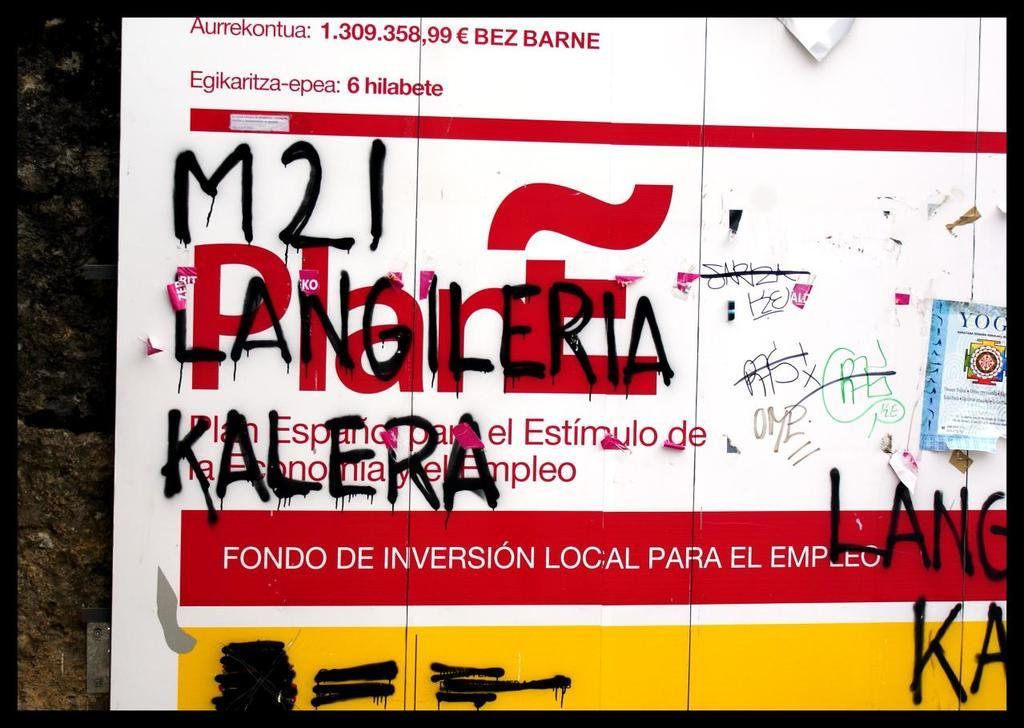What is the main object in the image? There is a board in the image. What is the board attached to? The board is attached to a black and brown color surface. What can be seen on the board? There is writing on the board. Can you see any bones attached to the chain on the boat in the image? There is no boat, chain, or bone present in the image; it only features a board with writing on it. 